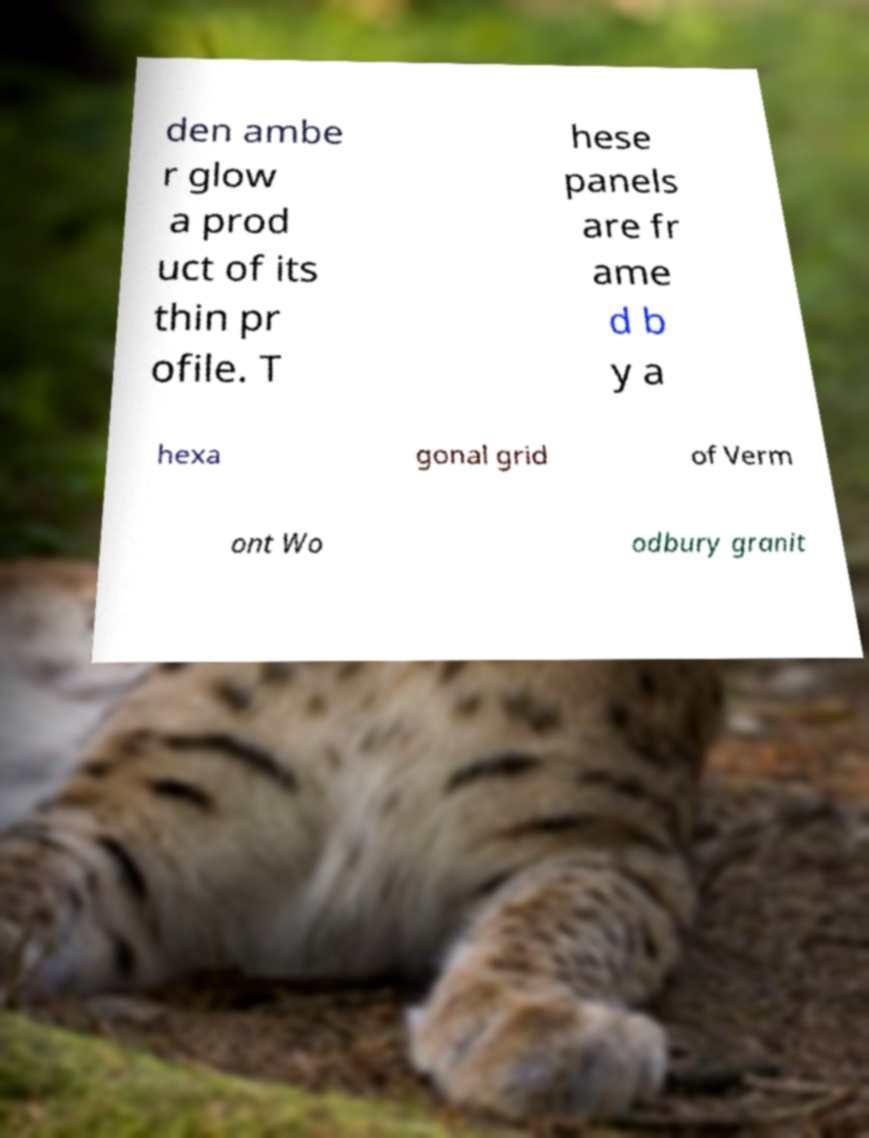Could you extract and type out the text from this image? den ambe r glow a prod uct of its thin pr ofile. T hese panels are fr ame d b y a hexa gonal grid of Verm ont Wo odbury granit 